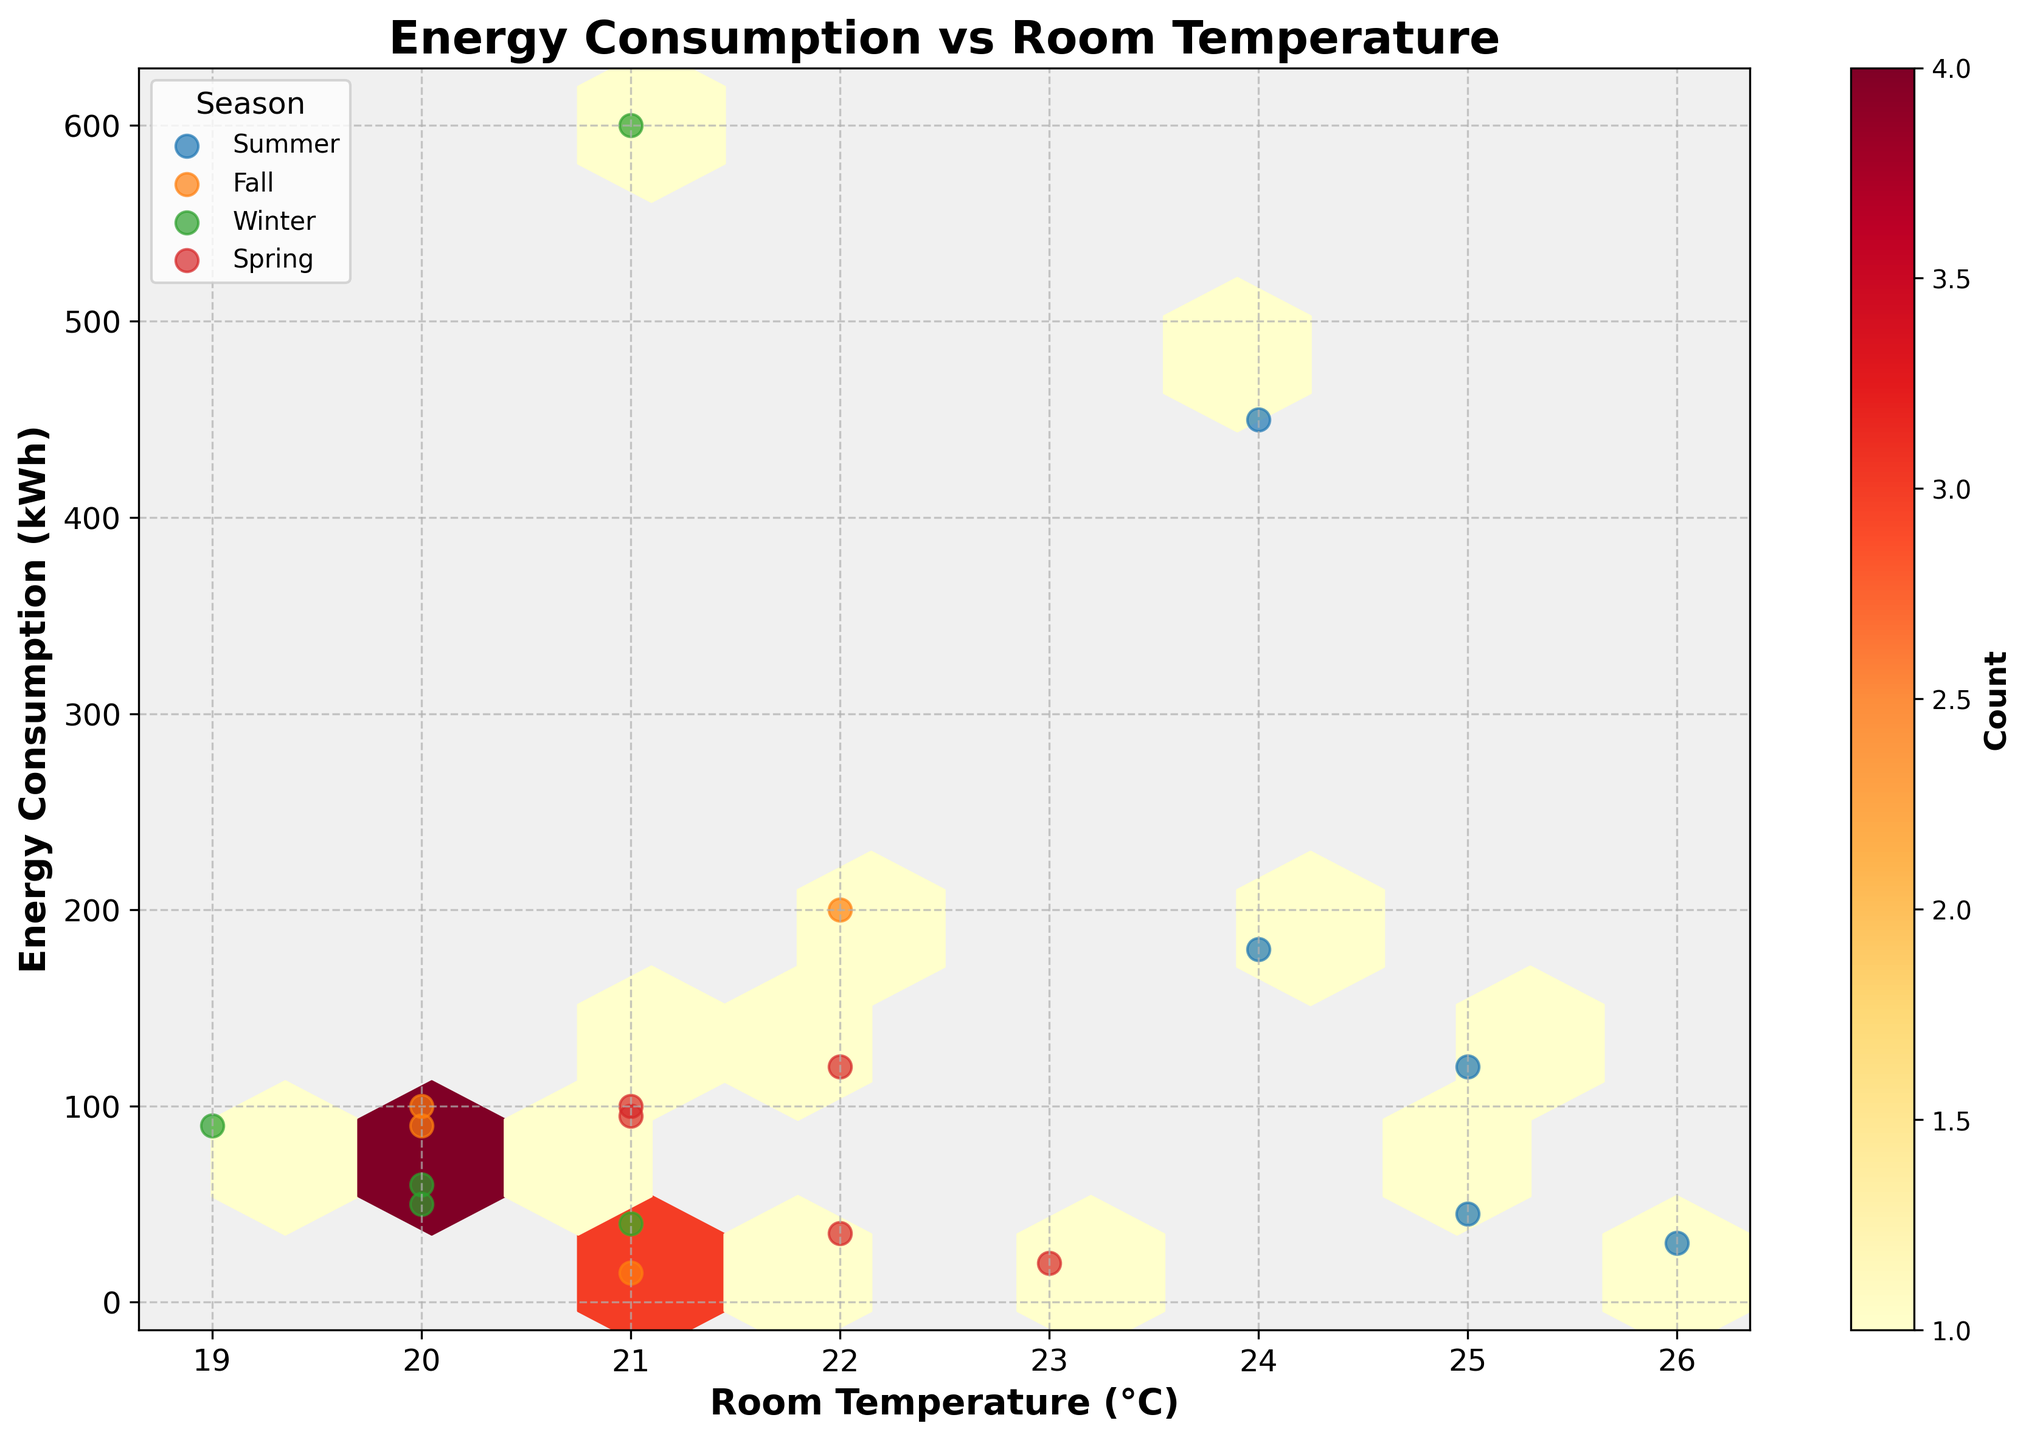What is the title of the plot? The title of the plot is displayed at the top center of the figure and helps to understand the overall purpose of the visualization.
Answer: Energy Consumption vs Room Temperature What two variables are being plotted on the x and y axes? The x-axis represents room temperature in degrees Celsius, and the y-axis represents energy consumption in kilowatt-hours, as indicated by the axis labels.
Answer: Room Temperature (°C) and Energy Consumption (kWh) Which season shows the highest energy consumption on average? By observing the scatter points marked by different colors for each season, the winter points appear to have the highest energy consumption overall.
Answer: Winter How does energy consumption vary with room temperature across different seasons? The plot shows hexagonal bins with color intensity indicating the density of points; scatter points for individual seasons further help observe the trends. There is generally higher energy consumption in winter and summer, and lower in spring and fall.
Answer: Winter and summer have higher, spring and fall have lower energy consumption Are there any temperatures that have low counts of energy consumption data points? The color intensity of the hexagonal bins indicates the number of data points, with lighter colors representing fewer points. Temperatures around 19°C to 24°C appear to have fewer data points.
Answer: 19°C to 24°C Which appliance likely consumes the most energy and in which season? By considering the highest energy consumption value in the plot, the Heating System in winter is likely to consume the most, as indicated by the high energy consumption points.
Answer: Heating System in Winter What is the count label of the color bar on the right of the hexbin plot? The color bar shows different color intensities representing counts. The label of this color bar is 'Count,' which indicates the number of data points within each bin.
Answer: Count What is the spread of energy consumption for room temperatures of 21°C? Observing the horizontal spread of points around 21°C on the x-axis, the energy consumption varies from low values around 15 kWh to high values up to 600 kWh.
Answer: 15 kWh to 600 kWh Comparing the seasons, which one shows the least energy consumption for a similar temperature range? By comparing the scatter points for similar temperatures (e.g., 21°C-23°C), fall season shows generally lower energy consumption values compared to other seasons.
Answer: Fall What room temperature range has the highest frequency of energy consumption data points? The densest hexagons, indicated by the darkest colors, appear around the 20-21°C range, suggesting this range has the highest frequency of data points.
Answer: 20-21°C 